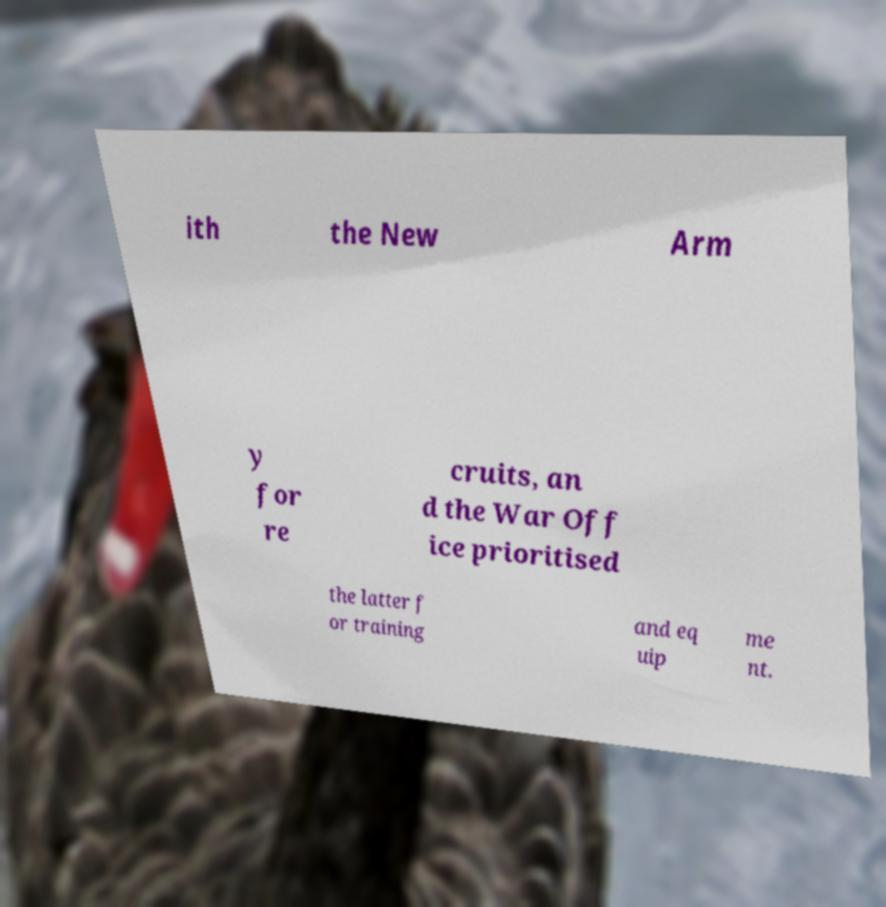Could you extract and type out the text from this image? ith the New Arm y for re cruits, an d the War Off ice prioritised the latter f or training and eq uip me nt. 